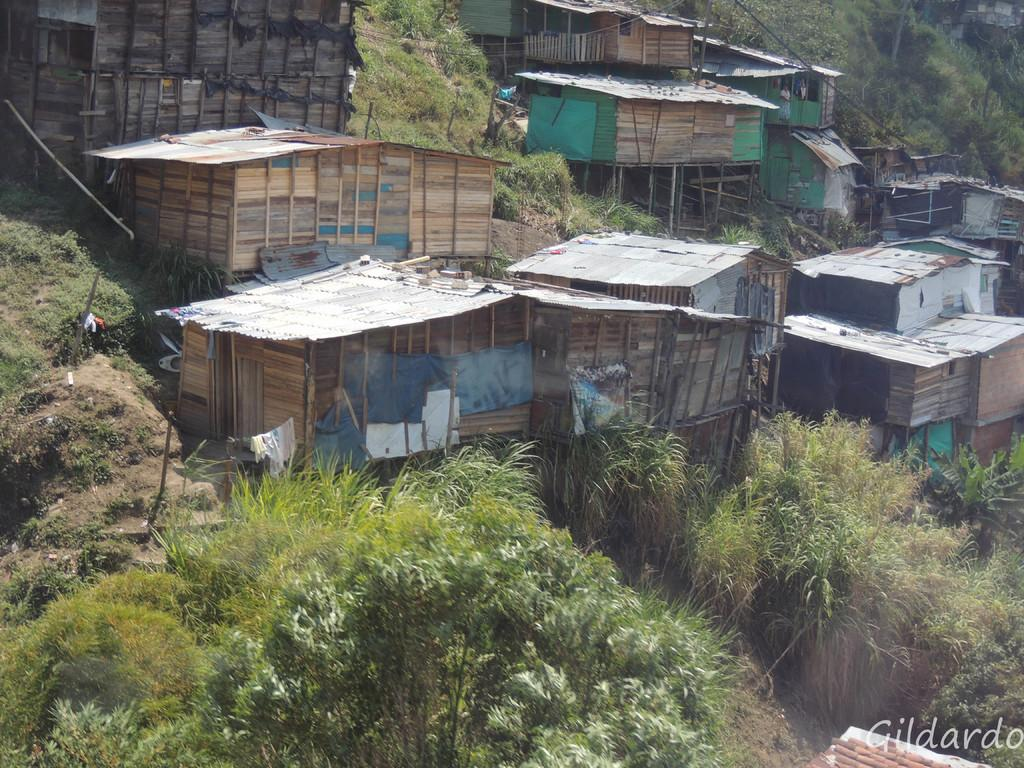What type of structures are visible in the image? There are wooden sheds in the image. What type of vegetation can be seen in the image? There are plants, grass, and trees in the image. What material are the sticks in the image made of? The sticks in the image are made of wood. What type of items are hanging in the image? There are clothes in the image. Can you tell me the agreement between the parent and the child in the image? There is no parent or child present in the image, so there is no agreement to discuss. What type of back is visible in the image? There is no back visible in the image; it features wooden sheds, plants, grass, trees, wooden sticks, and clothes. 